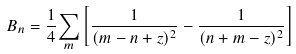<formula> <loc_0><loc_0><loc_500><loc_500>B _ { n } = { \frac { 1 } { 4 } } { \sum _ { m } } \left [ { \frac { 1 } { ( m - n + z ) ^ { 2 } } } - { \frac { 1 } { ( n + m - z ) ^ { 2 } } } \right ]</formula> 